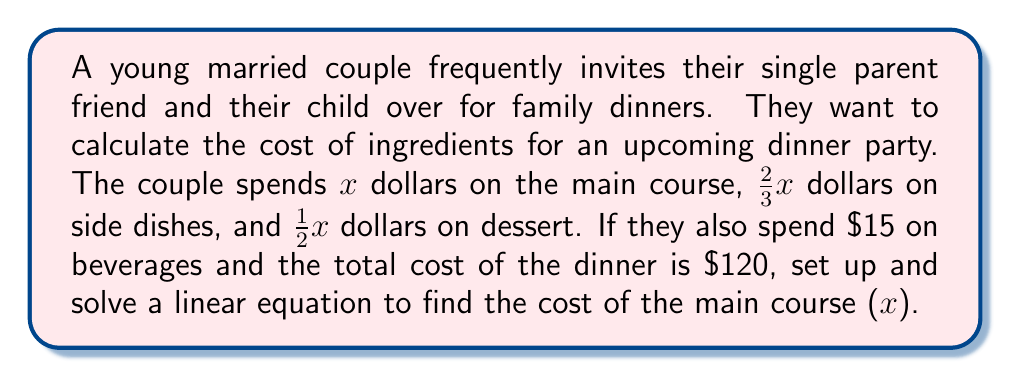Can you answer this question? Let's break this problem down step-by-step:

1) First, let's identify the components of our linear equation:
   - Main course: $x$
   - Side dishes: $\frac{2}{3}x$
   - Dessert: $\frac{1}{2}x$
   - Beverages: $15 (constant)
   - Total cost: $120

2) Now, we can set up our linear equation:
   $$ x + \frac{2}{3}x + \frac{1}{2}x + 15 = 120 $$

3) Let's simplify the left side of the equation:
   $$ (1 + \frac{2}{3} + \frac{1}{2})x + 15 = 120 $$
   $$ (\frac{6}{6} + \frac{4}{6} + \frac{3}{6})x + 15 = 120 $$
   $$ \frac{13}{6}x + 15 = 120 $$

4) Now, let's solve for $x$:
   $$ \frac{13}{6}x = 120 - 15 $$
   $$ \frac{13}{6}x = 105 $$
   $$ x = 105 \cdot \frac{6}{13} $$
   $$ x = \frac{630}{13} $$
   $$ x = 48.46 $$

5) Since we're dealing with currency, we'll round to the nearest cent:
   $$ x \approx 48.46 $$

Therefore, the cost of the main course is $48.46.
Answer: $48.46 